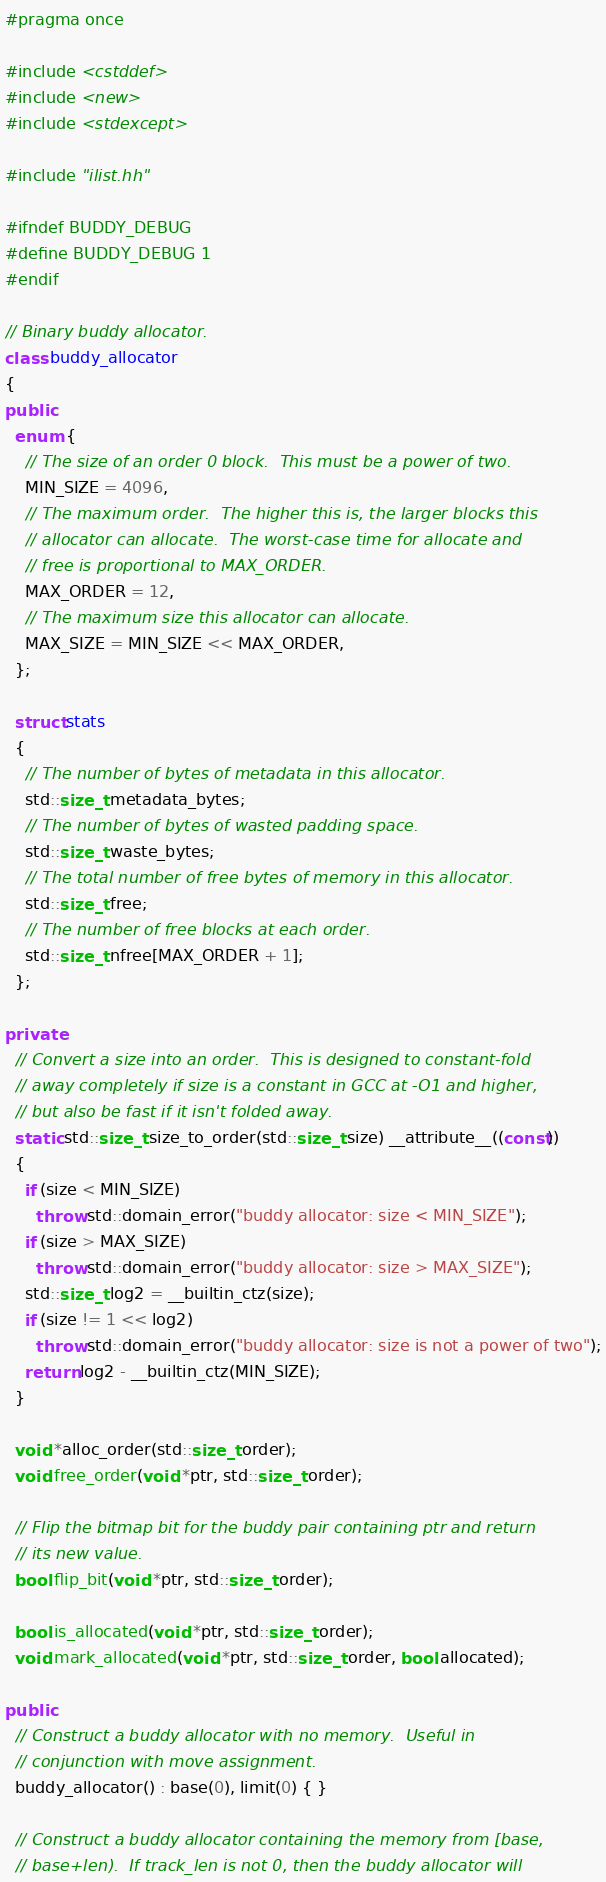<code> <loc_0><loc_0><loc_500><loc_500><_C++_>#pragma once

#include <cstddef>
#include <new>
#include <stdexcept>

#include "ilist.hh"

#ifndef BUDDY_DEBUG
#define BUDDY_DEBUG 1
#endif

// Binary buddy allocator.
class buddy_allocator
{
public:
  enum {
    // The size of an order 0 block.  This must be a power of two.
    MIN_SIZE = 4096,
    // The maximum order.  The higher this is, the larger blocks this
    // allocator can allocate.  The worst-case time for allocate and
    // free is proportional to MAX_ORDER.
    MAX_ORDER = 12,
    // The maximum size this allocator can allocate.
    MAX_SIZE = MIN_SIZE << MAX_ORDER,
  };

  struct stats
  {
    // The number of bytes of metadata in this allocator.
    std::size_t metadata_bytes;
    // The number of bytes of wasted padding space.
    std::size_t waste_bytes;
    // The total number of free bytes of memory in this allocator.
    std::size_t free;
    // The number of free blocks at each order.
    std::size_t nfree[MAX_ORDER + 1];
  };

private:
  // Convert a size into an order.  This is designed to constant-fold
  // away completely if size is a constant in GCC at -O1 and higher,
  // but also be fast if it isn't folded away.
  static std::size_t size_to_order(std::size_t size) __attribute__((const))
  {
    if (size < MIN_SIZE)
      throw std::domain_error("buddy allocator: size < MIN_SIZE");
    if (size > MAX_SIZE)
      throw std::domain_error("buddy allocator: size > MAX_SIZE");
    std::size_t log2 = __builtin_ctz(size);
    if (size != 1 << log2)
      throw std::domain_error("buddy allocator: size is not a power of two");
    return log2 - __builtin_ctz(MIN_SIZE);
  }

  void *alloc_order(std::size_t order);
  void free_order(void *ptr, std::size_t order);

  // Flip the bitmap bit for the buddy pair containing ptr and return
  // its new value.
  bool flip_bit(void *ptr, std::size_t order);

  bool is_allocated(void *ptr, std::size_t order);
  void mark_allocated(void *ptr, std::size_t order, bool allocated);

public:
  // Construct a buddy allocator with no memory.  Useful in
  // conjunction with move assignment.
  buddy_allocator() : base(0), limit(0) { }

  // Construct a buddy allocator containing the memory from [base,
  // base+len).  If track_len is not 0, then the buddy allocator will</code> 